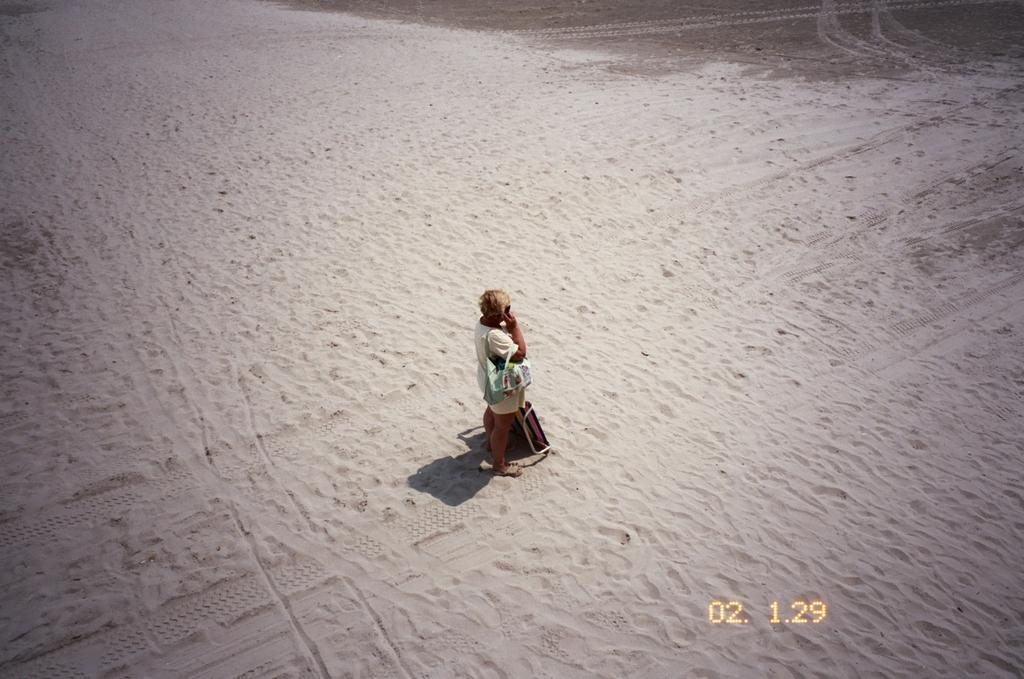Who is the main subject in the image? There is a person in the center of the image. What is the person wearing? The person is wearing a bag. What is the person holding in the image? The person is holding an object. What can be seen on the ground in the image? There is an object on the sand. Can you read any text in the image? Yes, there is some text visible in the image. What type of needle is being used by the person in the image? There is no needle present in the image. How does the person's temper affect the scene in the image? The person's temper is not mentioned or depicted in the image, so it cannot be determined how it affects the scene. 